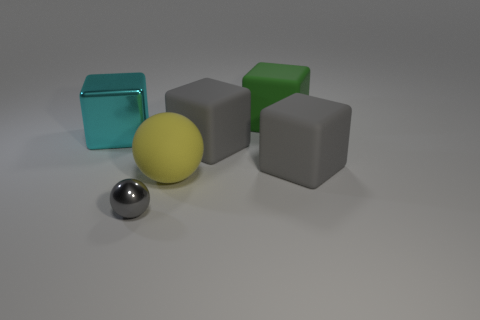There is a metallic object that is on the left side of the small metal sphere; is its shape the same as the green object?
Offer a terse response. Yes. How many objects are either big yellow rubber cubes or big blocks that are behind the large cyan cube?
Offer a terse response. 1. Is the material of the ball behind the tiny gray object the same as the gray sphere?
Give a very brief answer. No. Is there any other thing that is the same size as the metallic sphere?
Ensure brevity in your answer.  No. What material is the object in front of the sphere behind the gray metal ball?
Provide a succinct answer. Metal. Are there more large blocks left of the small shiny thing than large yellow objects behind the metallic block?
Offer a terse response. Yes. The gray metallic thing has what size?
Offer a very short reply. Small. There is a big matte block that is right of the green object; is its color the same as the metallic sphere?
Make the answer very short. Yes. There is a tiny shiny sphere that is in front of the yellow thing; is there a large green object right of it?
Ensure brevity in your answer.  Yes. Is the number of small gray balls that are in front of the small gray metallic sphere less than the number of large gray matte objects to the right of the green cube?
Your answer should be compact. Yes. 